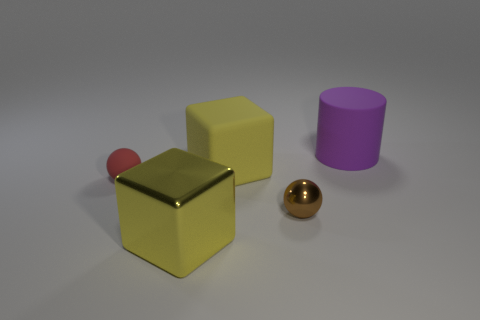Add 4 yellow rubber cylinders. How many objects exist? 9 Subtract all blocks. How many objects are left? 3 Add 4 tiny red spheres. How many tiny red spheres are left? 5 Add 4 large green matte balls. How many large green matte balls exist? 4 Subtract 1 red spheres. How many objects are left? 4 Subtract all yellow matte cubes. Subtract all small blue matte cylinders. How many objects are left? 4 